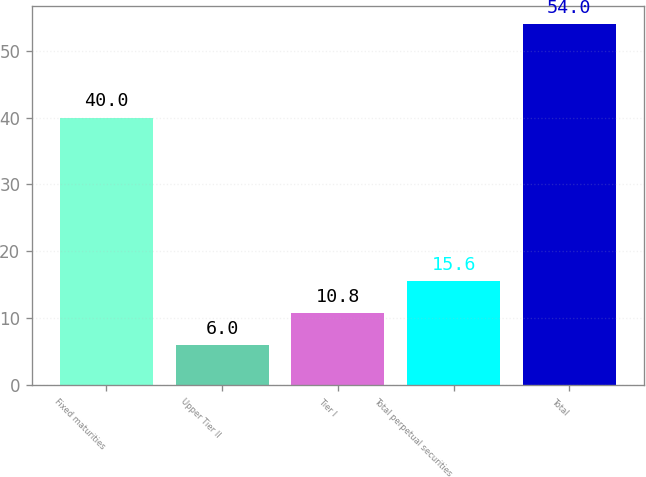<chart> <loc_0><loc_0><loc_500><loc_500><bar_chart><fcel>Fixed maturities<fcel>Upper Tier II<fcel>Tier I<fcel>Total perpetual securities<fcel>Total<nl><fcel>40<fcel>6<fcel>10.8<fcel>15.6<fcel>54<nl></chart> 